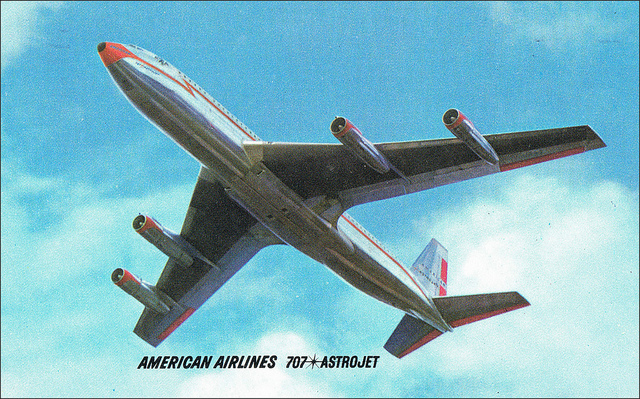Identify the text displayed in this image. AMERICAN AIRLINES 707 ASTROJET 